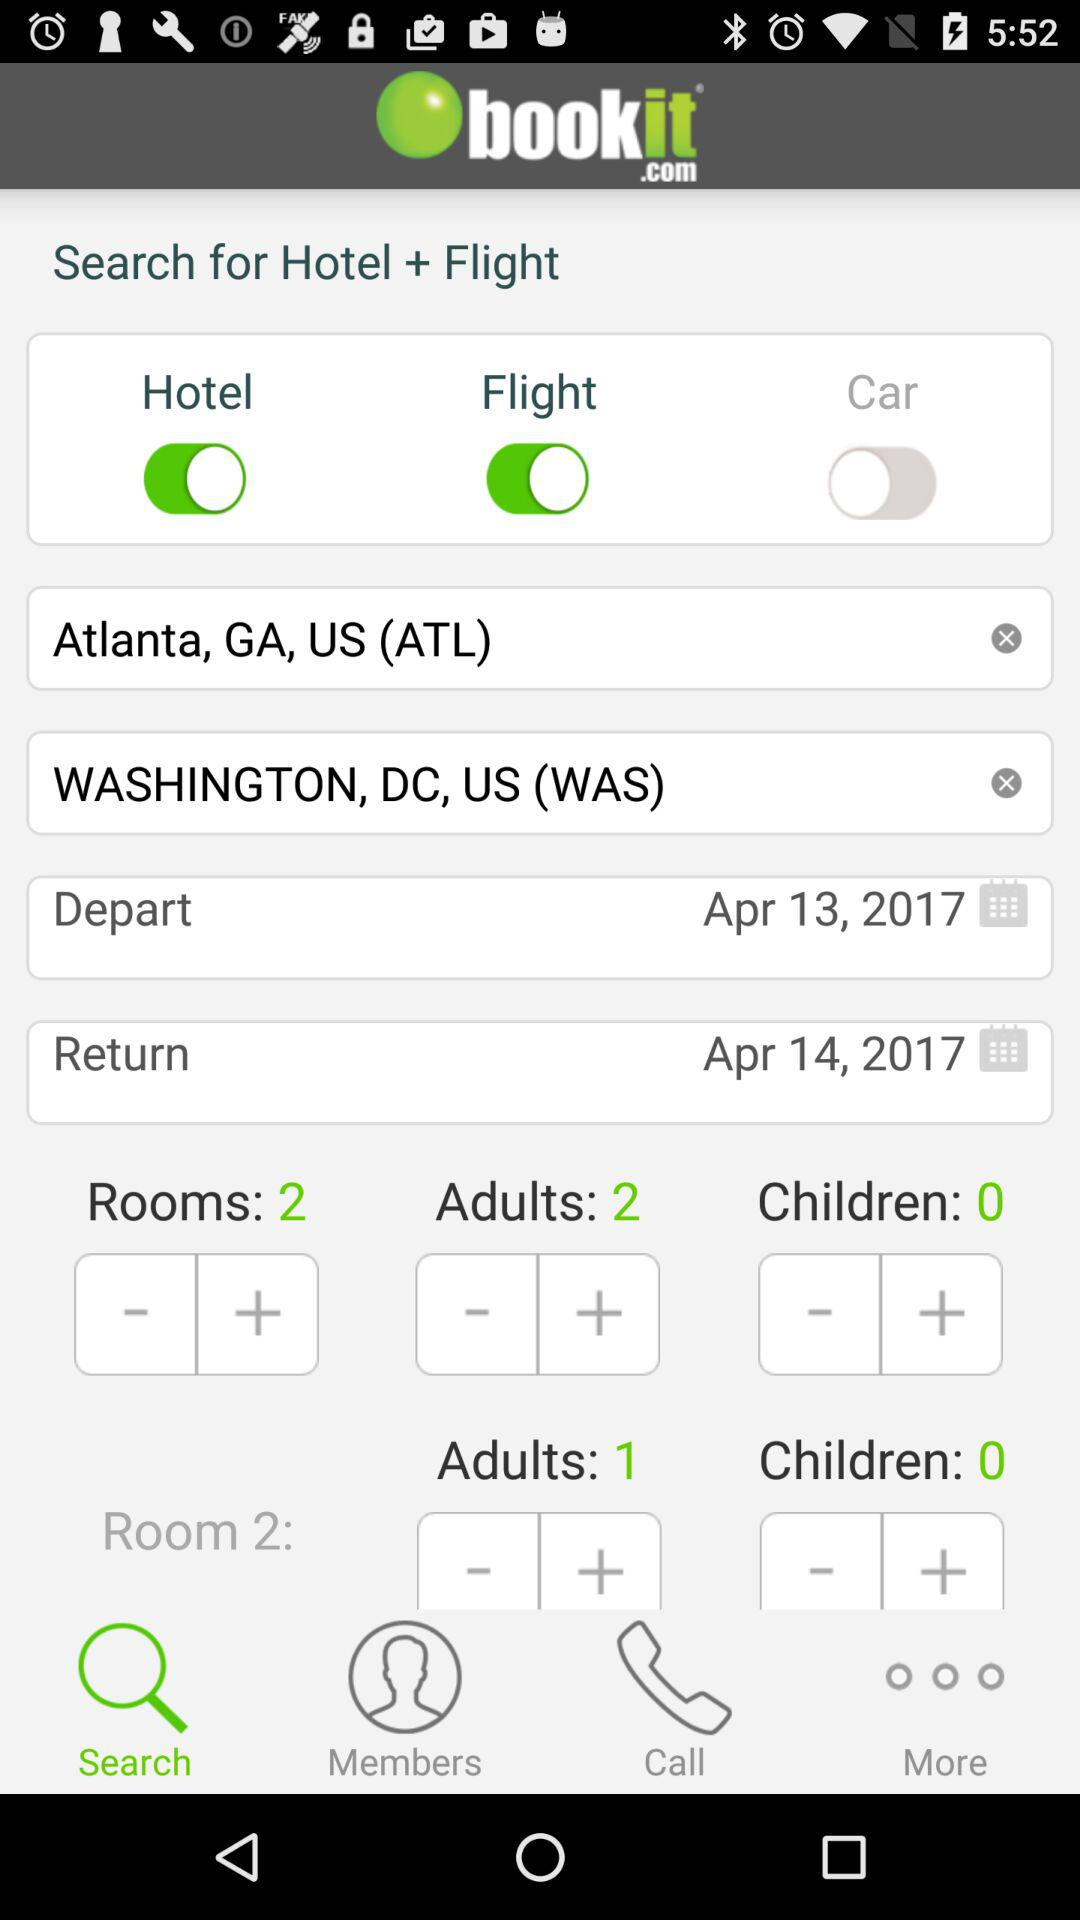How many rooms are selected? There are 2 rooms selected. 